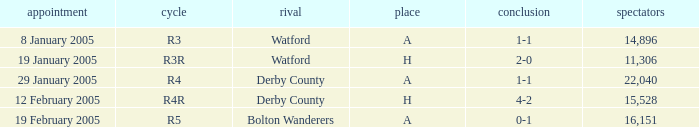What is the date where the round is R3? 8 January 2005. Parse the full table. {'header': ['appointment', 'cycle', 'rival', 'place', 'conclusion', 'spectators'], 'rows': [['8 January 2005', 'R3', 'Watford', 'A', '1-1', '14,896'], ['19 January 2005', 'R3R', 'Watford', 'H', '2-0', '11,306'], ['29 January 2005', 'R4', 'Derby County', 'A', '1-1', '22,040'], ['12 February 2005', 'R4R', 'Derby County', 'H', '4-2', '15,528'], ['19 February 2005', 'R5', 'Bolton Wanderers', 'A', '0-1', '16,151']]} 